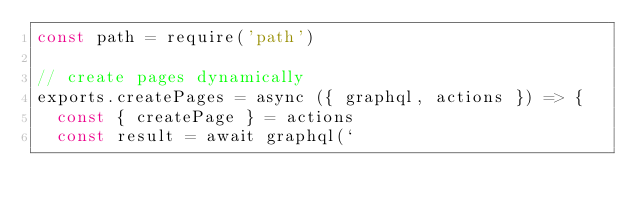Convert code to text. <code><loc_0><loc_0><loc_500><loc_500><_JavaScript_>const path = require('path')

// create pages dynamically
exports.createPages = async ({ graphql, actions }) => {
  const { createPage } = actions
  const result = await graphql(`</code> 